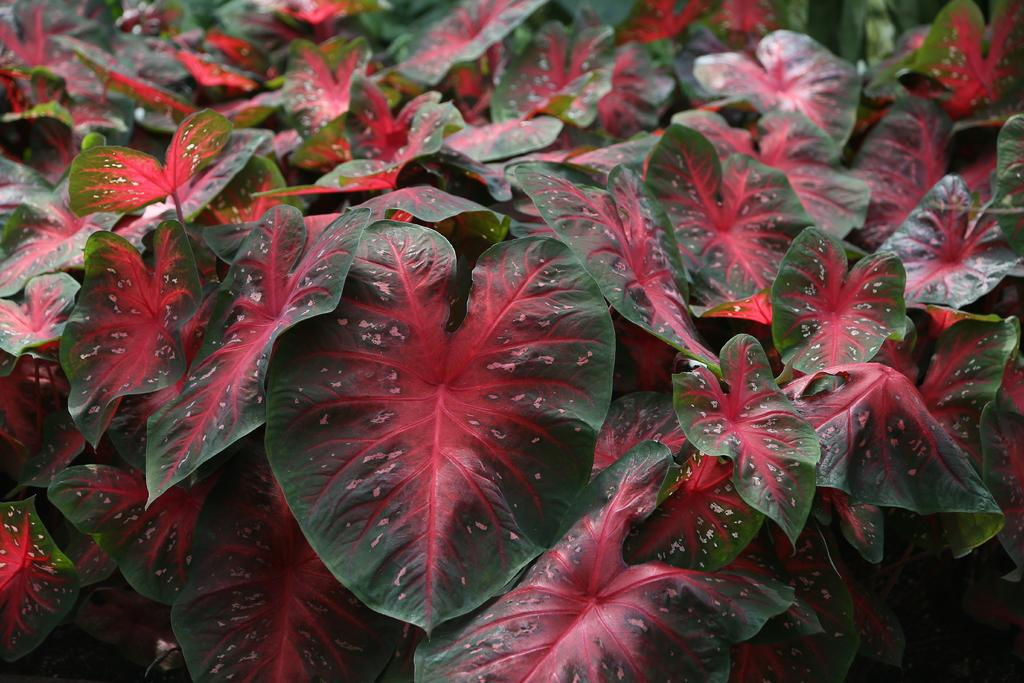What type of vegetation can be seen in the image? There are leaves in the image. How many farmers are present in the image? There are no farmers present in the image; it only features leaves. What type of bead can be seen in the image? There are no beads present in the image; it only features leaves. 